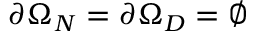Convert formula to latex. <formula><loc_0><loc_0><loc_500><loc_500>\partial \Omega _ { N } = \partial \Omega _ { D } = \emptyset</formula> 